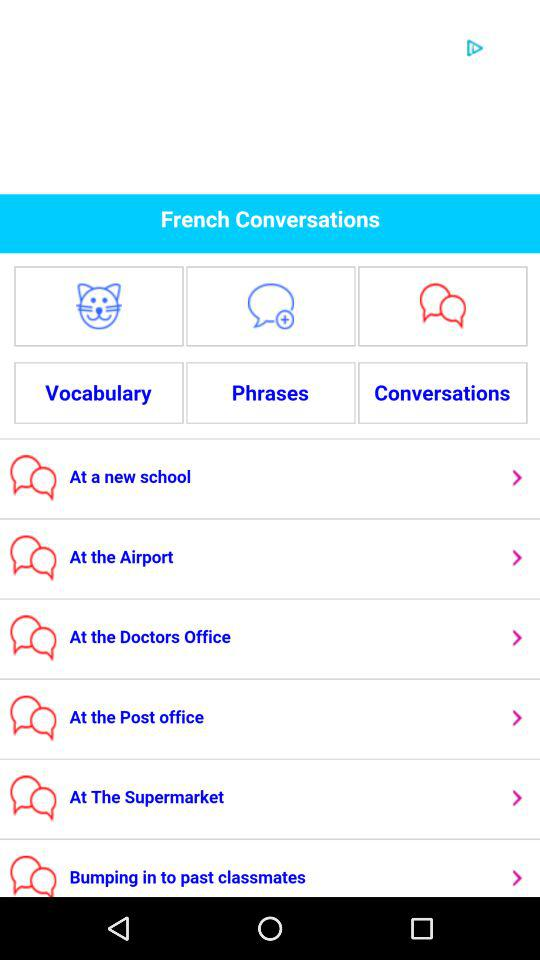How many conversation topics are there?
Answer the question using a single word or phrase. 6 